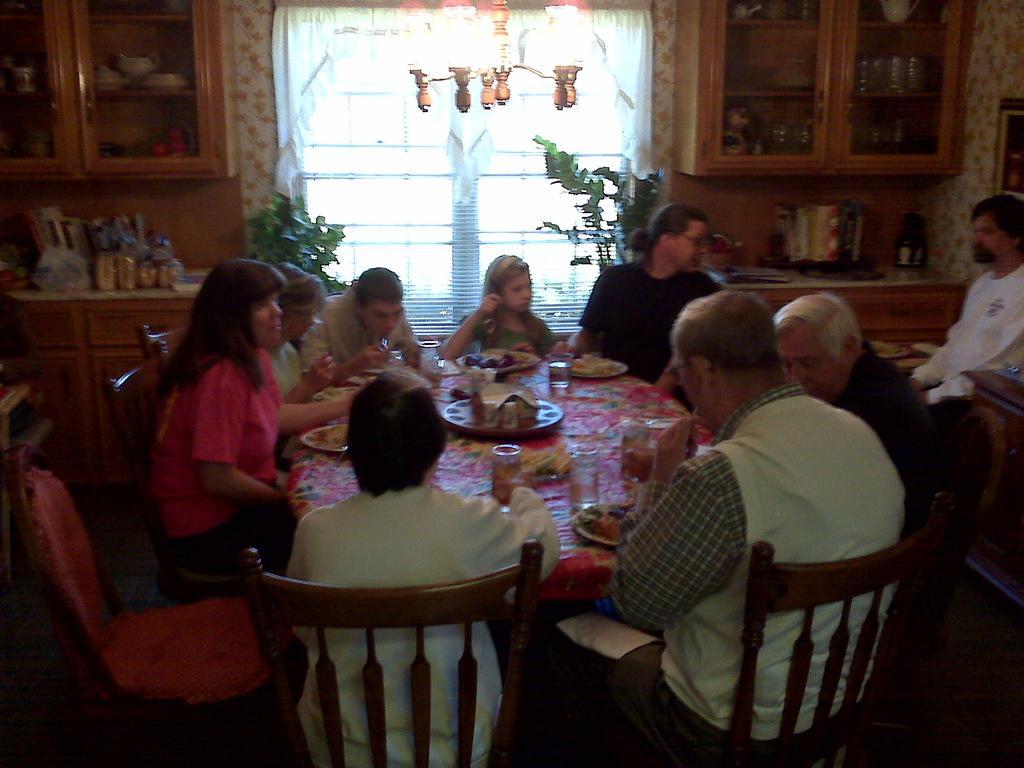In one or two sentences, can you explain what this image depicts? In this image there is a group of persons who are sitting on a chair near to a dining table. On the table there is a plate ,glass, cloth and food. On the right there is a person who is wearing white T-shirt sitting on a table. On the top right there is a shelf which having a glass. On the top we can see a chandelier. On the background there is a window. 